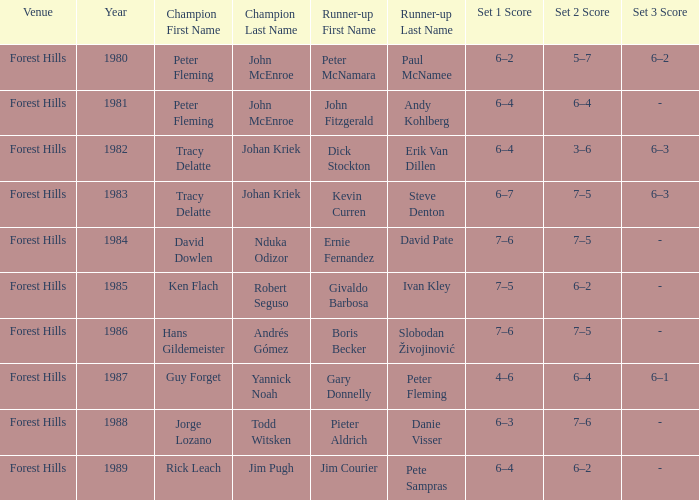Who were the champions in 1988? Jorge Lozano Todd Witsken. 